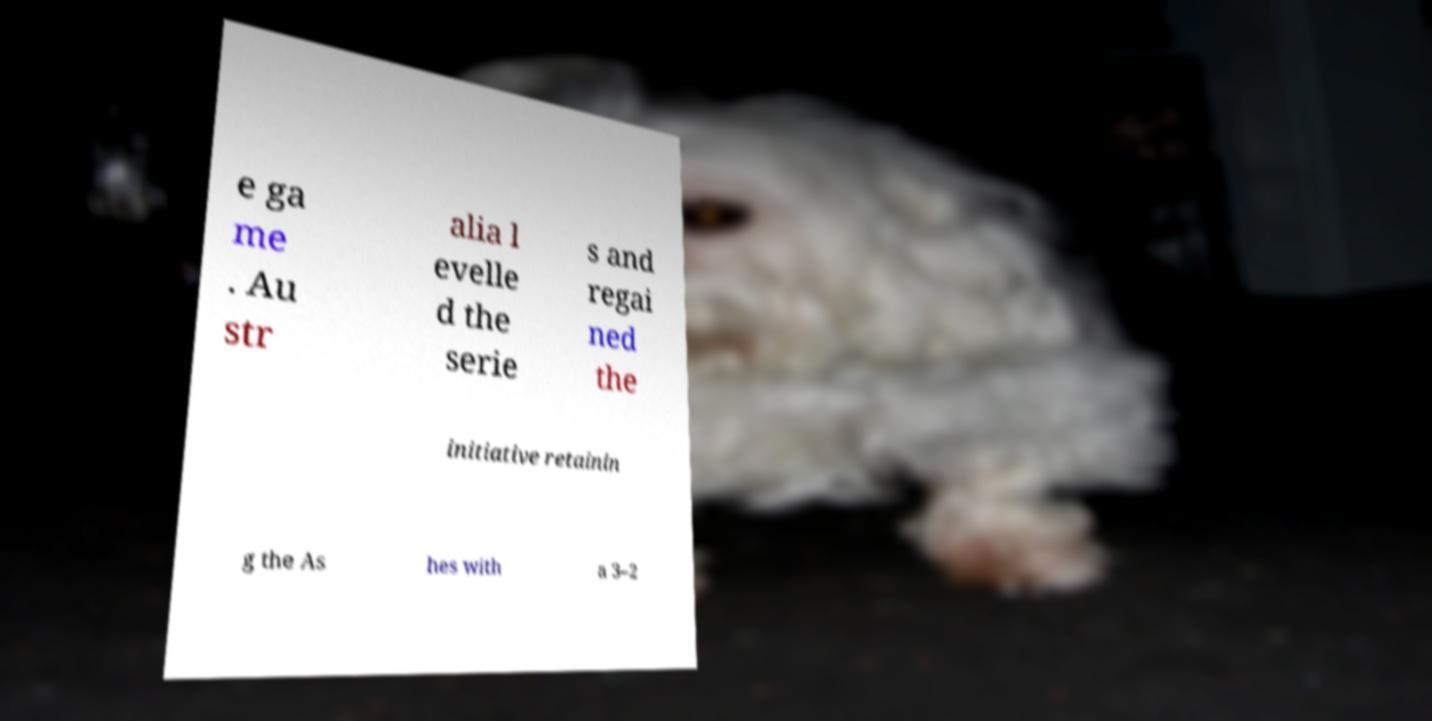Please identify and transcribe the text found in this image. e ga me . Au str alia l evelle d the serie s and regai ned the initiative retainin g the As hes with a 3–2 